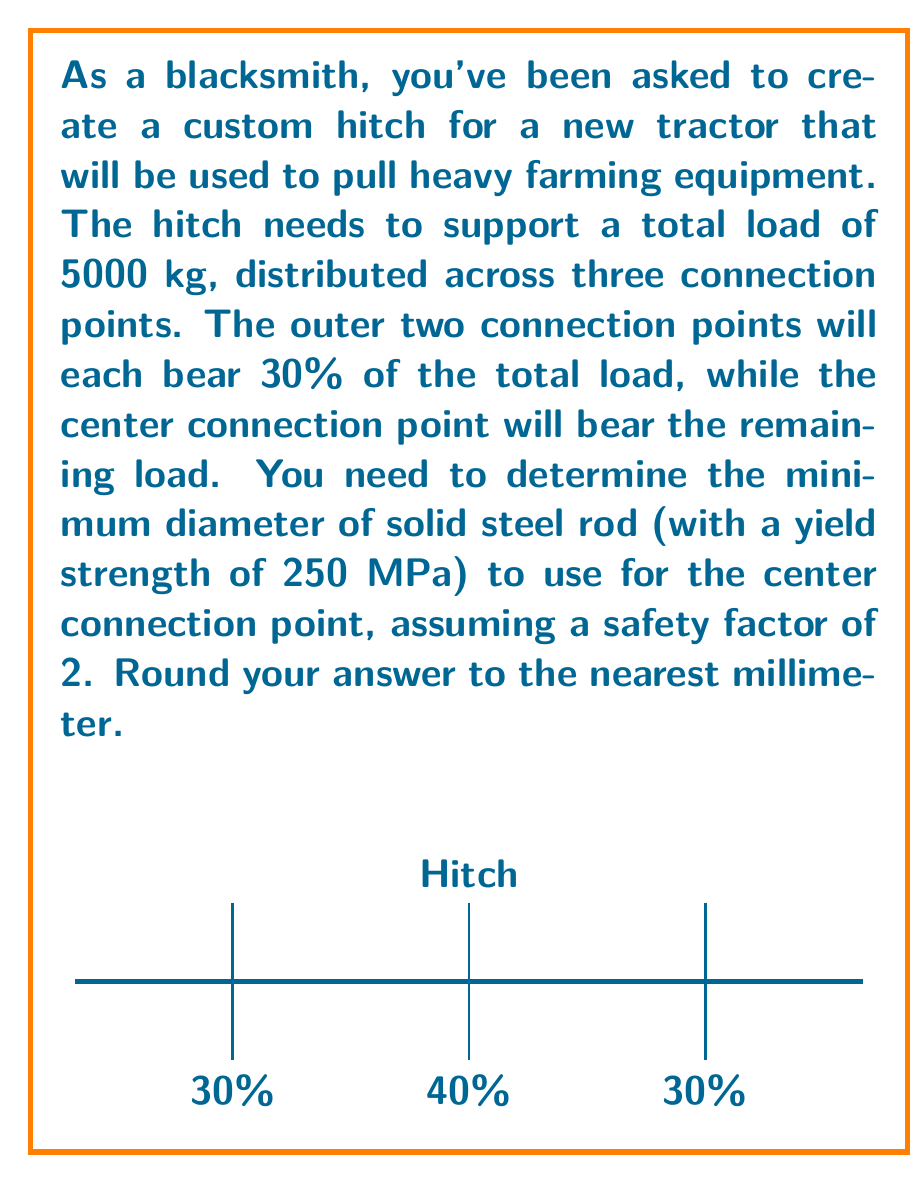Teach me how to tackle this problem. Let's approach this step-by-step:

1) First, calculate the load on the center connection point:
   40% of 5000 kg = $0.40 \times 5000 \text{ kg} = 2000 \text{ kg}$

2) Convert this load to Newtons:
   $F = 2000 \text{ kg} \times 9.81 \text{ m/s}^2 = 19620 \text{ N}$

3) The stress formula for a circular cross-section is:
   $$\sigma = \frac{F}{A} = \frac{F}{\pi r^2}$$
   where $\sigma$ is stress, $F$ is force, and $r$ is the radius of the rod.

4) Given the yield strength of 250 MPa and a safety factor of 2, the maximum allowable stress is:
   $$\sigma_{max} = \frac{250 \text{ MPa}}{2} = 125 \text{ MPa} = 125 \times 10^6 \text{ Pa}$$

5) Substituting into the stress formula:
   $$125 \times 10^6 = \frac{19620}{\pi r^2}$$

6) Solving for $r$:
   $$r^2 = \frac{19620}{\pi \times 125 \times 10^6} = 4.9896 \times 10^{-5} \text{ m}^2$$
   $$r = \sqrt{4.9896 \times 10^{-5}} = 0.007063 \text{ m} = 7.063 \text{ mm}$$

7) The diameter is twice the radius:
   $d = 2r = 2 \times 7.063 = 14.126 \text{ mm}$

8) Rounding to the nearest millimeter:
   $d \approx 14 \text{ mm}$
Answer: 14 mm 